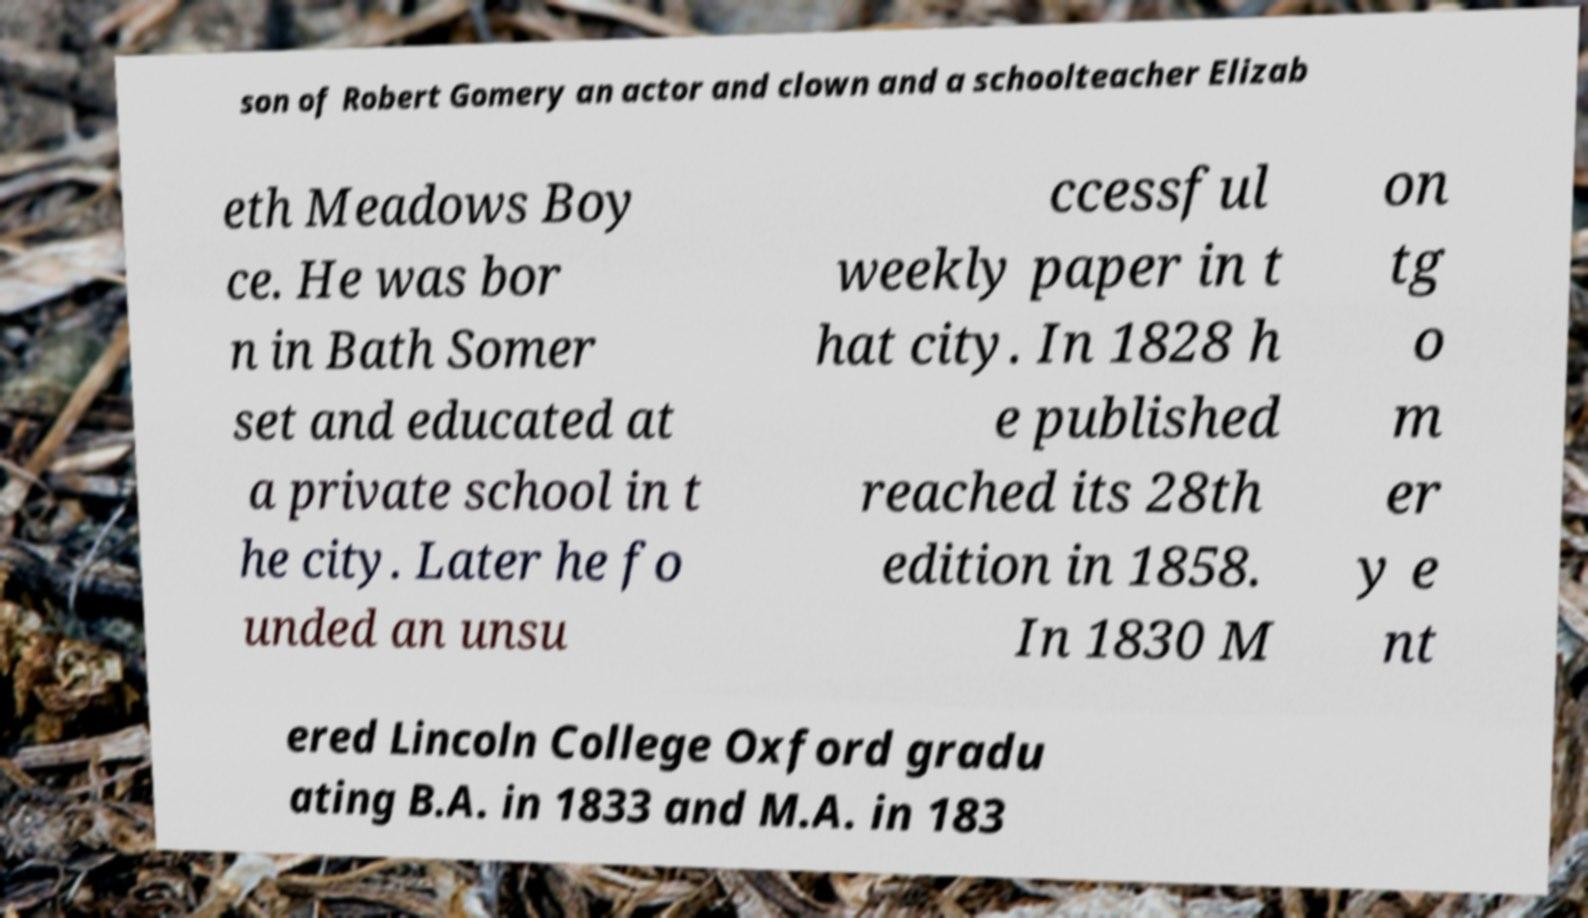For documentation purposes, I need the text within this image transcribed. Could you provide that? son of Robert Gomery an actor and clown and a schoolteacher Elizab eth Meadows Boy ce. He was bor n in Bath Somer set and educated at a private school in t he city. Later he fo unded an unsu ccessful weekly paper in t hat city. In 1828 h e published reached its 28th edition in 1858. In 1830 M on tg o m er y e nt ered Lincoln College Oxford gradu ating B.A. in 1833 and M.A. in 183 